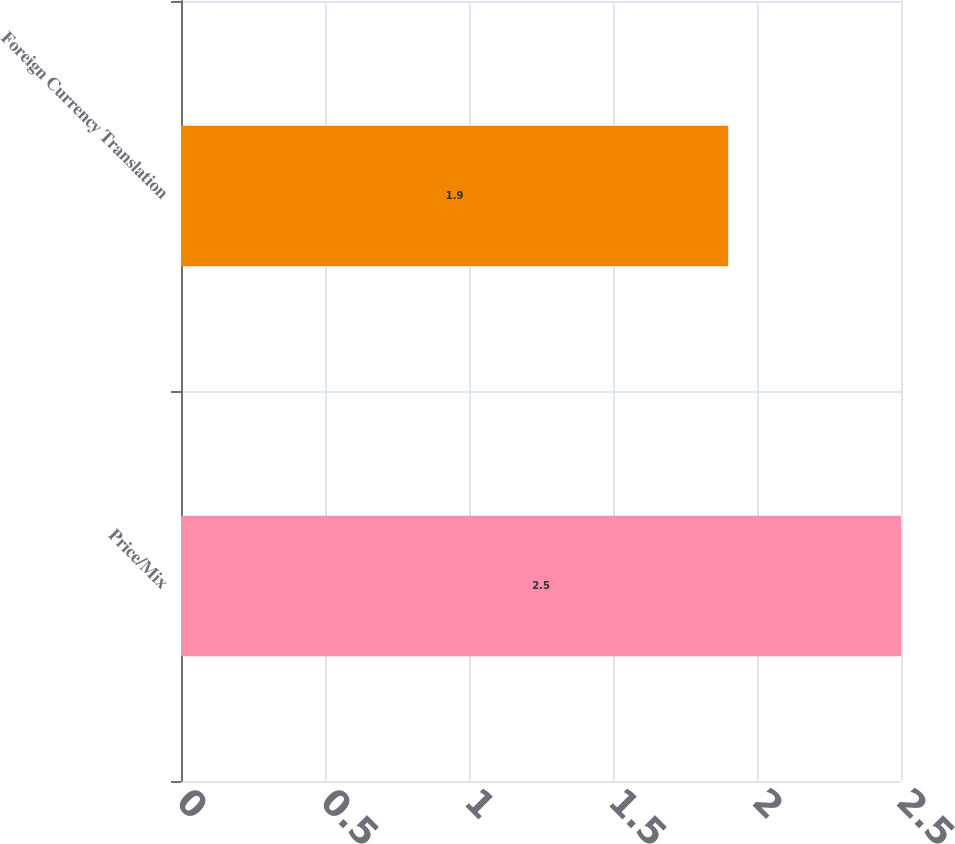Convert chart. <chart><loc_0><loc_0><loc_500><loc_500><bar_chart><fcel>Price/Mix<fcel>Foreign Currency Translation<nl><fcel>2.5<fcel>1.9<nl></chart> 